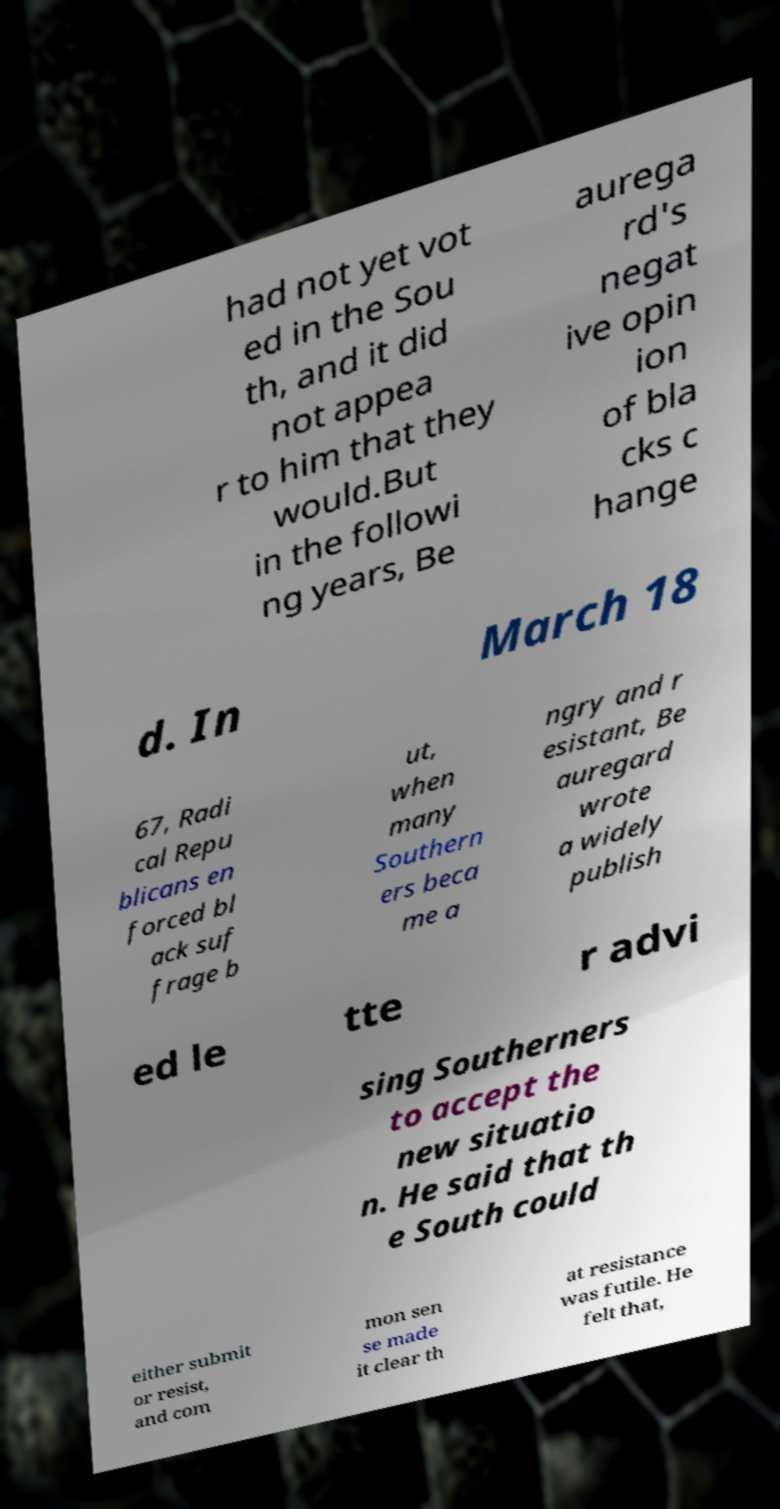I need the written content from this picture converted into text. Can you do that? had not yet vot ed in the Sou th, and it did not appea r to him that they would.But in the followi ng years, Be aurega rd's negat ive opin ion of bla cks c hange d. In March 18 67, Radi cal Repu blicans en forced bl ack suf frage b ut, when many Southern ers beca me a ngry and r esistant, Be auregard wrote a widely publish ed le tte r advi sing Southerners to accept the new situatio n. He said that th e South could either submit or resist, and com mon sen se made it clear th at resistance was futile. He felt that, 